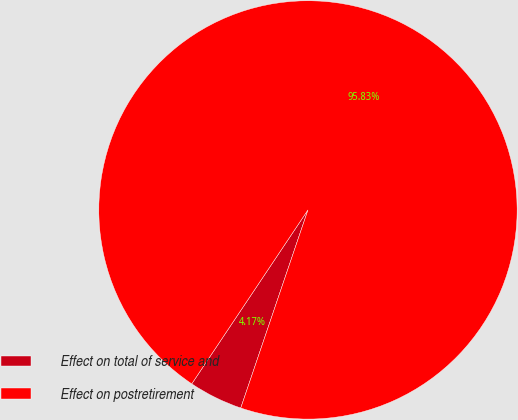Convert chart to OTSL. <chart><loc_0><loc_0><loc_500><loc_500><pie_chart><fcel>Effect on total of service and<fcel>Effect on postretirement<nl><fcel>4.17%<fcel>95.83%<nl></chart> 